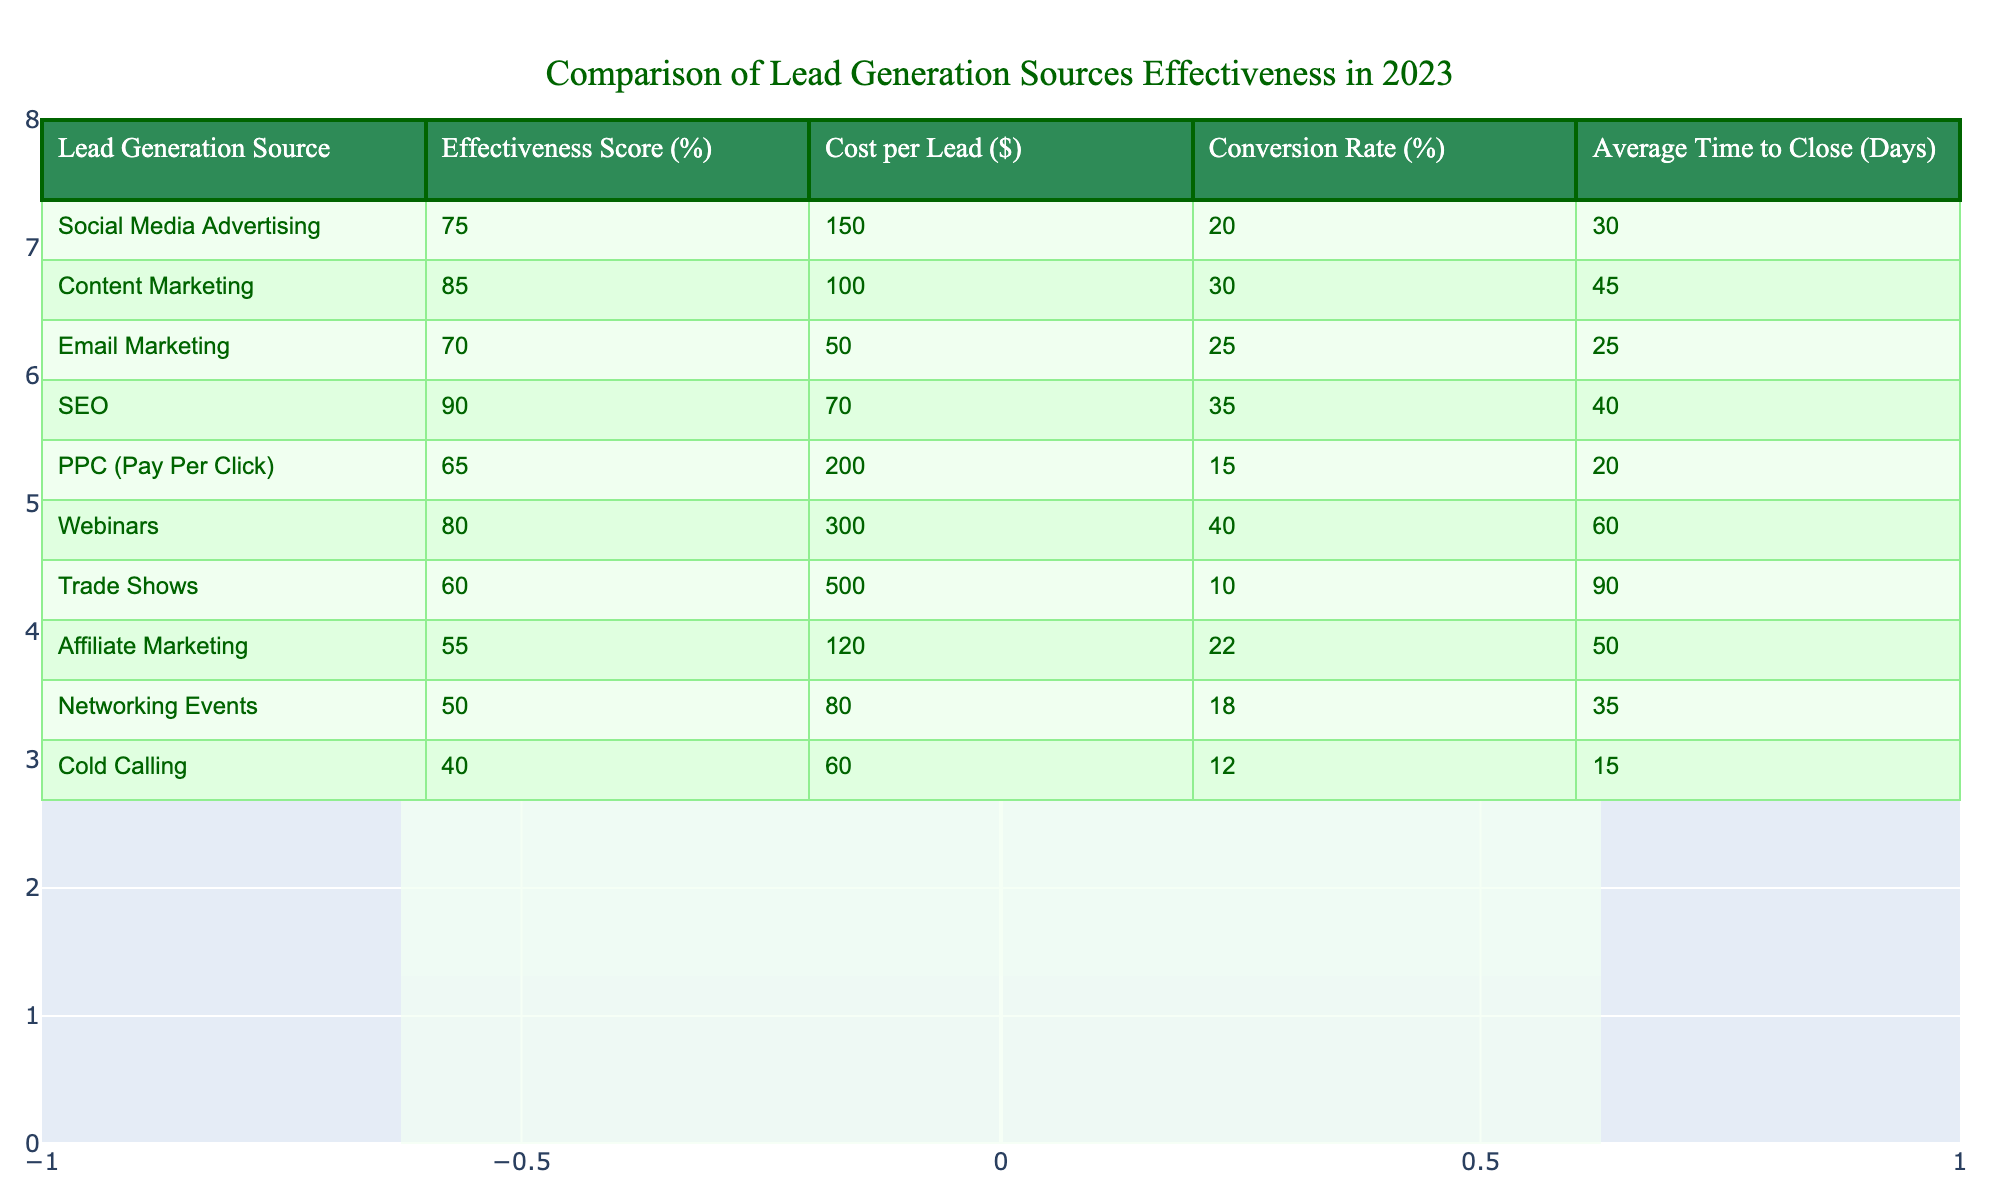What is the effectiveness score of SEO? The effectiveness score for SEO is found in the table under the column "Effectiveness Score (%)". The corresponding row for SEO indicates a score of 90%.
Answer: 90 Which lead generation source has the highest conversion rate? The conversion rates for each source can be compared by looking at the "Conversion Rate (%)" values. SEO has the highest conversion rate at 35%.
Answer: SEO What is the average cost per lead for Content Marketing and Email Marketing combined? The cost per lead for Content Marketing is $100 and for Email Marketing is $50. Adding these two values gives $100 + $50 = $150, and then dividing by 2 gives an average of $75.
Answer: 75 Is the effectiveness score for Webinars greater than that of Trade Shows? By comparing the effectiveness scores from the table, Webinars has a score of 80% and Trade Shows has a score of 60%. Since 80% is greater than 60%, the answer is yes.
Answer: Yes What is the average time to close for the sources with an effectiveness score greater than 70%? The sources with scores greater than 70% are: Social Media Advertising (30 days), Content Marketing (45 days), SEO (40 days), and Webinars (60 days). Adding these gives 30 + 45 + 40 + 60 = 175 days. Dividing by the number of sources (4) results in an average of 175 / 4 = 43.75 days.
Answer: 43.75 Which generation source is the least effective, and what is its effectiveness score? The effectiveness scores indicate that Affiliate Marketing has the lowest score at 55%.
Answer: 55 What is the difference in effectiveness score between PPC and Cold Calling? The effectiveness score for PPC is 65% and for Cold Calling it is 40%. Subtracting gives 65 - 40 = 25%.
Answer: 25 Which lead generation source has the highest cost per lead? The cost per lead values are examined, and Trade Shows, at $500, has the highest cost.
Answer: Trade Shows What is the total conversion rate for all lead generation sources listed? The conversion rates are added together: 20 + 30 + 25 + 35 + 15 + 40 + 10 + 22 + 18 + 12 =  270%.
Answer: 270 